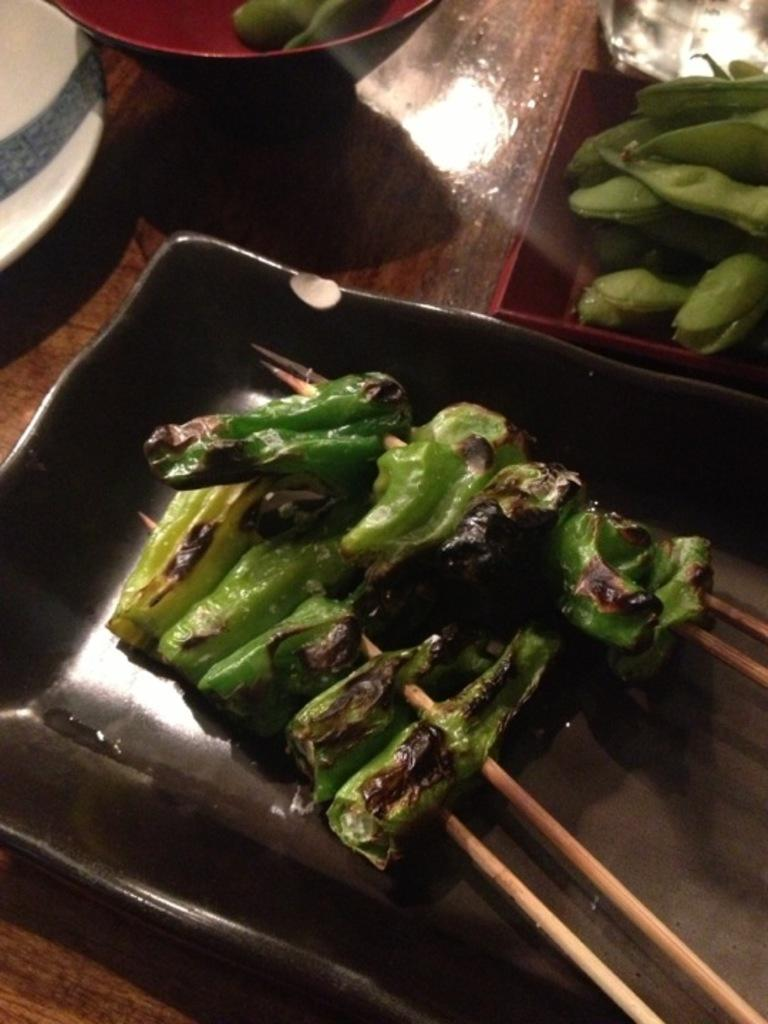What type of items can be seen in containers in the image? There are food items in containers in the image. What color is the object that stands out in the image? There is a white-colored object in the image. What type of utensils are present in the image? There are wooden sticks in the image. What type of action is the bed performing in the image? There is no bed present in the image, so it cannot perform any actions. 